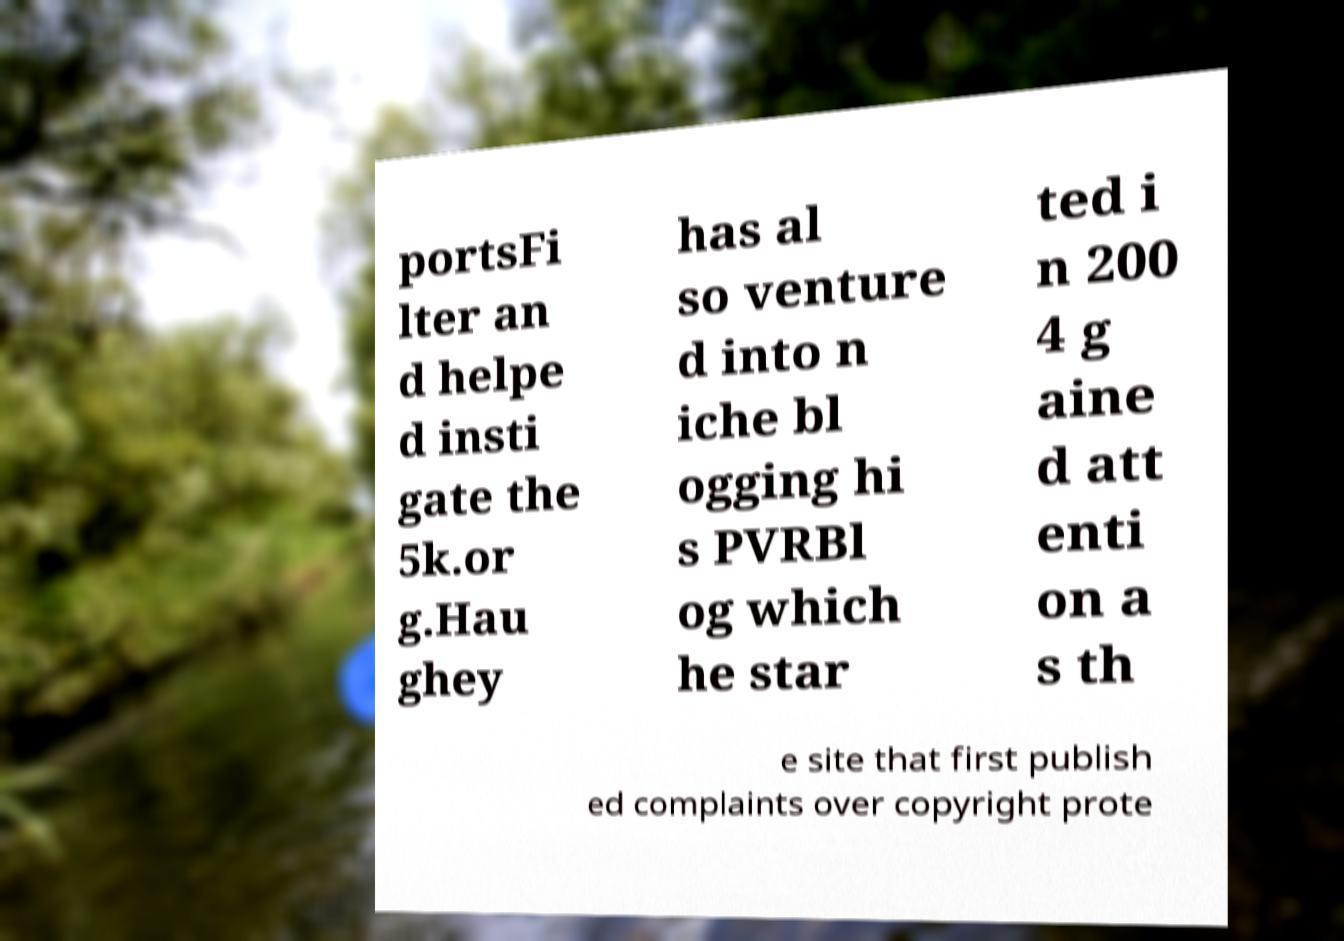Can you read and provide the text displayed in the image?This photo seems to have some interesting text. Can you extract and type it out for me? portsFi lter an d helpe d insti gate the 5k.or g.Hau ghey has al so venture d into n iche bl ogging hi s PVRBl og which he star ted i n 200 4 g aine d att enti on a s th e site that first publish ed complaints over copyright prote 